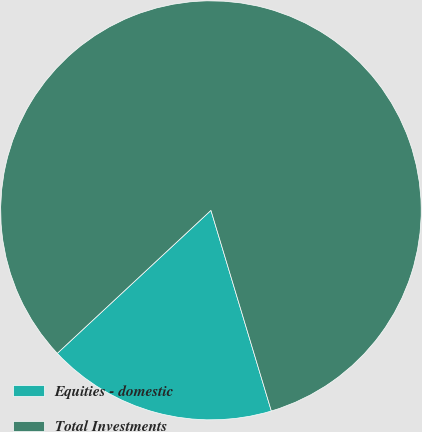<chart> <loc_0><loc_0><loc_500><loc_500><pie_chart><fcel>Equities - domestic<fcel>Total Investments<nl><fcel>17.68%<fcel>82.32%<nl></chart> 